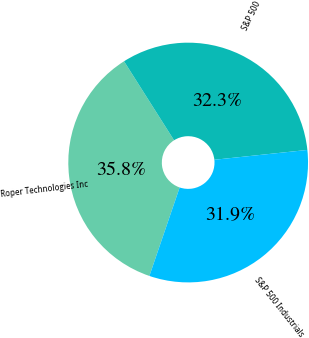Convert chart to OTSL. <chart><loc_0><loc_0><loc_500><loc_500><pie_chart><fcel>Roper Technologies Inc<fcel>S&P 500<fcel>S&P 500 Industrials<nl><fcel>35.77%<fcel>32.31%<fcel>31.92%<nl></chart> 